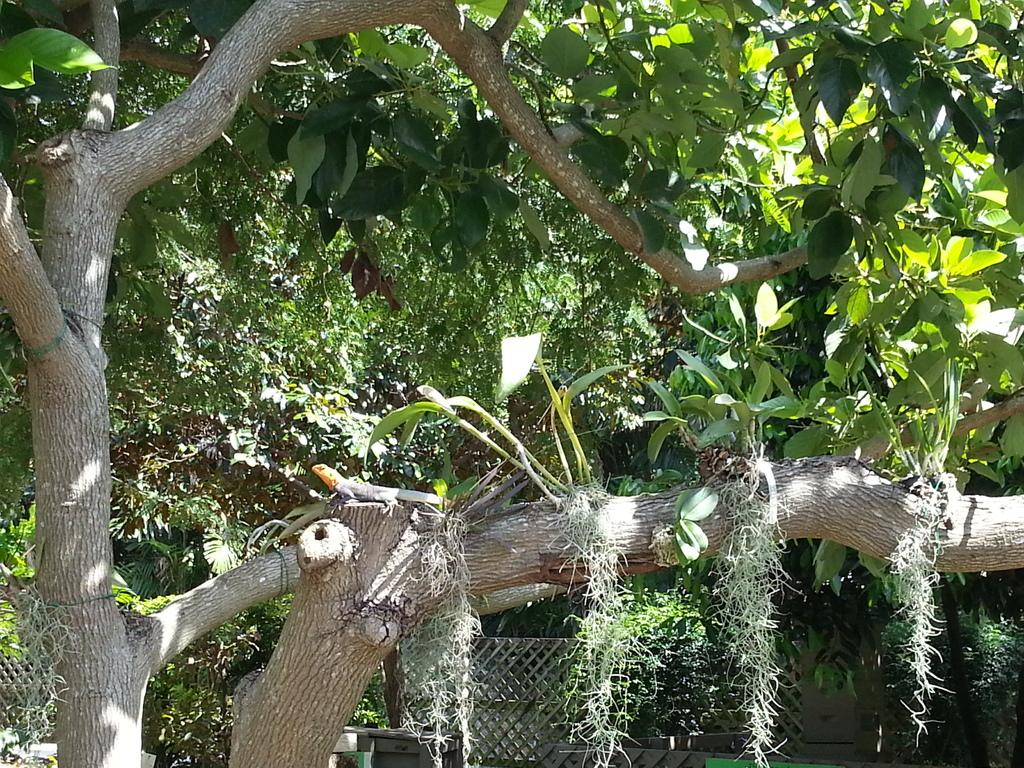What type of animal is in the image? There is a lizard in the image. Where is the lizard located? The lizard is on a tree branch. What can be seen in the background of the image? There are trees with branches and leaves in the image. What is at the bottom of the image? There is a fence at the bottom of the image. How many letters are included in the list of items the lizard is carrying? There is no list or items mentioned in the image, and the lizard is not carrying anything. 